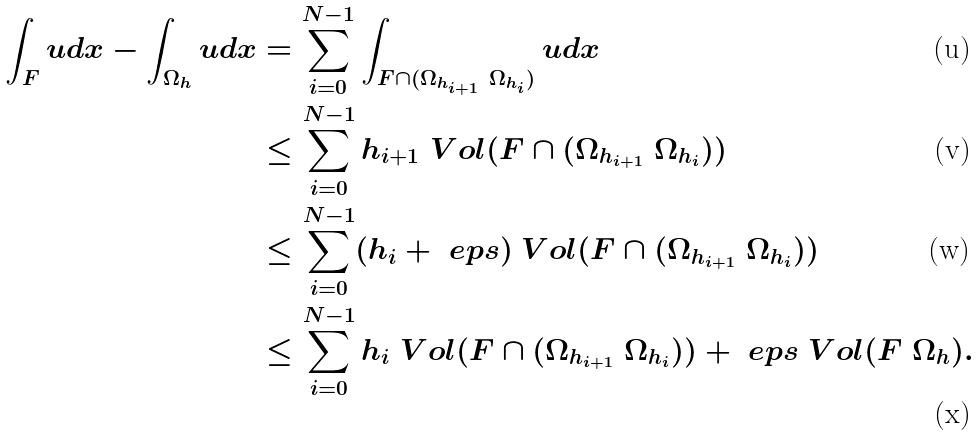Convert formula to latex. <formula><loc_0><loc_0><loc_500><loc_500>\int _ { F } u d x - \int _ { \Omega _ { h } } u d x & = \sum _ { i = 0 } ^ { N - 1 } \int _ { F \cap ( \Omega _ { h _ { i + 1 } } \ \Omega _ { h _ { i } } ) } u d x \\ & \leq \sum _ { i = 0 } ^ { N - 1 } h _ { i + 1 } \ V o l ( F \cap ( \Omega _ { h _ { i + 1 } } \ \Omega _ { h _ { i } } ) ) \\ & \leq \sum _ { i = 0 } ^ { N - 1 } ( h _ { i } + \ e p s ) \ V o l ( F \cap ( \Omega _ { h _ { i + 1 } } \ \Omega _ { h _ { i } } ) ) \\ & \leq \sum _ { i = 0 } ^ { N - 1 } h _ { i } \ V o l ( F \cap ( \Omega _ { h _ { i + 1 } } \ \Omega _ { h _ { i } } ) ) + \ e p s \ V o l ( F \ \Omega _ { h } ) .</formula> 